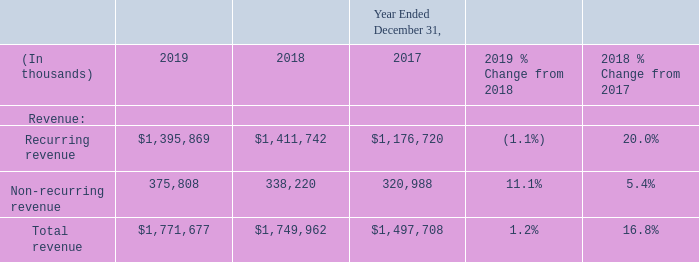Revenue
Recurring revenue consists of subscription-based software sales, support and maintenance revenue, recurring transactions revenue and recurring revenue from managed services solutions, such as outsourcing, private cloud hosting and revenue cycle management. Non-recurring revenue consists of perpetual software licenses sales, hardware resale and non-recurring transactions revenue, and project-based client services revenue.
Year Ended December 31, 2019 Compared with the Year Ended December 31, 2018
Recurring revenue decreased during the year ended December 31, 2019 compared to prior year due to known attrition within the EIS and other businesses partially offset with growth in subscription revenue. The sale of the OneContent business on April 2, 2018 also contributed to the decline in recurring revenue. The OneContent business was acquired as part of the EIS Business acquisition on October 2, 2017, and it contributed $13 million of recurring revenue during the first quarter of 2018, including $1 million of amortization of acquisition-related deferred revenue adjustments. Non-recurring revenue increased due to higher sales of perpetual software licenses for our acute solutions and hardware in 2019 compared to 2018, partially offset by lower client services revenue related to the timing of software activations.
The percentage of recurring and non-recurring revenue of our total revenue was 79% and 21%, respectively, during the year ended December 31, 2019 and 81% and 19%, respectively, during the year ended December 31, 2018.
Year Ended December 31, 2018 Compared with the Year Ended December 31, 2017
The increase in revenue for the year ended December 31, 2018 compared with the year ended December 31, 2017 was primarily driven by incremental revenue from the acquisitions of the EIS Business in the fourth quarter of 2017 and Practice Fusion in the first quarter of 2018. Total revenue includes the amortization of acquisition-related deferred revenue adjustments, which totaled $24 million and $29 million during the years ended December 31, 2018 and 2017, respectively. The growth in both recurring and non-recurring revenue for the year ended December 31, 2018 compared with the prior year was also largely driven by incremental revenue from the previously mentioned acquisitions.
The increase in revenue for the year ended December 31, 2018 compared with the year ended December 31, 2017 was primarily driven by incremental revenue from the acquisitions of the EIS Business in the fourth quarter of 2017 and Practice Fusion in the first quarter of 2018. Total revenue includes the amortization of acquisition-related deferred revenue adjustments, which totaled $24 million and $29 million during the years ended December 31, 2018 and 2017, respectively. The growth in both recurring and non-recurring revenue for the year ended December 31, 2018 compared with the prior year was also largely driven by incremental revenue from the previously mentioned acquisitions.
What is the recurring revenue in 2019?
Answer scale should be: thousand. $1,395,869. What is the recurring revenue in 2018?
Answer scale should be: thousand. $1,411,742. What is the recurring revenue in 2017?
Answer scale should be: thousand. $1,176,720. What was the change in the recurring revenue from 2018 to 2019?
Answer scale should be: thousand. 1,395,869 - 1,411,742
Answer: -15873. What is the average Non-recurring revenue between 2017-2019?
Answer scale should be: thousand. (375,808 + 338,220 + 320,988) / 3
Answer: 345005.33. What is the change in the total revenue from 2018 to 2019?
Answer scale should be: thousand. 1,771,677 - 1,749,962
Answer: 21715. 